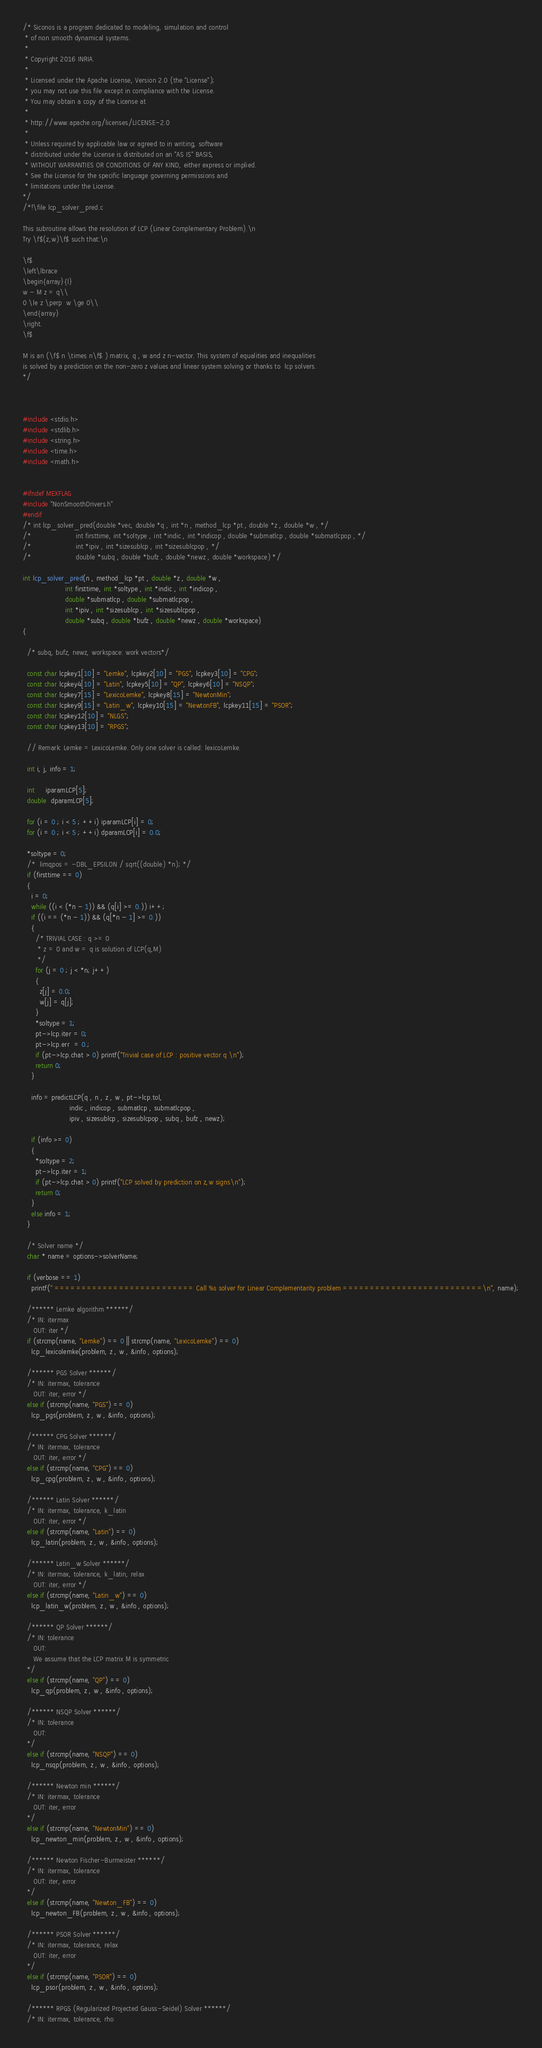<code> <loc_0><loc_0><loc_500><loc_500><_C_>/* Siconos is a program dedicated to modeling, simulation and control
 * of non smooth dynamical systems.
 *
 * Copyright 2016 INRIA.
 *
 * Licensed under the Apache License, Version 2.0 (the "License");
 * you may not use this file except in compliance with the License.
 * You may obtain a copy of the License at
 *
 * http://www.apache.org/licenses/LICENSE-2.0
 *
 * Unless required by applicable law or agreed to in writing, software
 * distributed under the License is distributed on an "AS IS" BASIS,
 * WITHOUT WARRANTIES OR CONDITIONS OF ANY KIND, either express or implied.
 * See the License for the specific language governing permissions and
 * limitations under the License.
*/
/*!\file lcp_solver_pred.c

This subroutine allows the resolution of LCP (Linear Complementary Problem).\n
Try \f$(z,w)\f$ such that:\n

\f$
\left\lbrace
\begin{array}{l}
w - M z = q\\
0 \le z \perp  w \ge 0\\
\end{array}
\right.
\f$

M is an (\f$ n \times n\f$ ) matrix, q , w and z n-vector. This system of equalities and inequalities
is solved by a prediction on the non-zero z values and linear system solving or thanks to  lcp solvers.
*/



#include <stdio.h>
#include <stdlib.h>
#include <string.h>
#include <time.h>
#include <math.h>


#ifndef MEXFLAG
#include "NonSmoothDrivers.h"
#endif
/* int lcp_solver_pred(double *vec, double *q , int *n , method_lcp *pt , double *z , double *w , */
/*                     int firsttime, int *soltype , int *indic , int *indicop , double *submatlcp , double *submatlcpop , */
/*                     int *ipiv , int *sizesublcp , int *sizesublcpop , */
/*                     double *subq , double *bufz , double *newz , double *workspace) */

int lcp_solver_pred(n , method_lcp *pt , double *z , double *w ,
                    int firsttime, int *soltype , int *indic , int *indicop ,
                    double *submatlcp , double *submatlcpop ,
                    int *ipiv , int *sizesublcp , int *sizesublcpop ,
                    double *subq , double *bufz , double *newz , double *workspace)
{

  /* subq, bufz, newz, workspace: work vectors*/

  const char lcpkey1[10] = "Lemke", lcpkey2[10] = "PGS", lcpkey3[10] = "CPG";
  const char lcpkey4[10] = "Latin", lcpkey5[10] = "QP", lcpkey6[10] = "NSQP";
  const char lcpkey7[15] = "LexicoLemke", lcpkey8[15] = "NewtonMin";
  const char lcpkey9[15] = "Latin_w", lcpkey10[15] = "NewtonFB", lcpkey11[15] = "PSOR";
  const char lcpkey12[10] = "NLGS";
  const char lcpkey13[10] = "RPGS";

  // Remark: Lemke = LexicoLemke. Only one solver is called: lexicoLemke.

  int i, j, info = 1;

  int     iparamLCP[5];
  double  dparamLCP[5];

  for (i = 0 ; i < 5 ; ++i) iparamLCP[i] = 0;
  for (i = 0 ; i < 5 ; ++i) dparamLCP[i] = 0.0;

  *soltype = 0;
  /*  limqpos = -DBL_EPSILON / sqrt((double) *n); */
  if (firsttime == 0)
  {
    i = 0;
    while ((i < (*n - 1)) && (q[i] >= 0.)) i++;
    if ((i == (*n - 1)) && (q[*n - 1] >= 0.))
    {
      /* TRIVIAL CASE : q >= 0
       * z = 0 and w = q is solution of LCP(q,M)
       */
      for (j = 0 ; j < *n; j++)
      {
        z[j] = 0.0;
        w[j] = q[j];
      }
      *soltype = 1;
      pt->lcp.iter = 0;
      pt->lcp.err  = 0.;
      if (pt->lcp.chat > 0) printf("Trivial case of LCP : positive vector q \n");
      return 0;
    }

    info = predictLCP(q , n , z , w , pt->lcp.tol,
                      indic , indicop , submatlcp , submatlcpop ,
                      ipiv , sizesublcp , sizesublcpop , subq , bufz , newz);

    if (info >= 0)
    {
      *soltype = 2;
      pt->lcp.iter = 1;
      if (pt->lcp.chat > 0) printf("LCP solved by prediction on z,w signs\n");
      return 0;
    }
    else info = 1;
  }

  /* Solver name */
  char * name = options->solverName;

  if (verbose == 1)
    printf(" ========================== Call %s solver for Linear Complementarity problem ==========================\n", name);

  /****** Lemke algorithm ******/
  /* IN: itermax
     OUT: iter */
  if (strcmp(name, "Lemke") == 0 || strcmp(name, "LexicoLemke") == 0)
    lcp_lexicolemke(problem, z , w , &info , options);

  /****** PGS Solver ******/
  /* IN: itermax, tolerance
     OUT: iter, error */
  else if (strcmp(name, "PGS") == 0)
    lcp_pgs(problem, z , w , &info , options);

  /****** CPG Solver ******/
  /* IN: itermax, tolerance
     OUT: iter, error */
  else if (strcmp(name, "CPG") == 0)
    lcp_cpg(problem, z , w , &info , options);

  /****** Latin Solver ******/
  /* IN: itermax, tolerance, k_latin
     OUT: iter, error */
  else if (strcmp(name, "Latin") == 0)
    lcp_latin(problem, z , w , &info , options);

  /****** Latin_w Solver ******/
  /* IN: itermax, tolerance, k_latin, relax
     OUT: iter, error */
  else if (strcmp(name, "Latin_w") == 0)
    lcp_latin_w(problem, z , w , &info , options);

  /****** QP Solver ******/
  /* IN: tolerance
     OUT:
     We assume that the LCP matrix M is symmetric
  */
  else if (strcmp(name, "QP") == 0)
    lcp_qp(problem, z , w , &info , options);

  /****** NSQP Solver ******/
  /* IN: tolerance
     OUT:
  */
  else if (strcmp(name, "NSQP") == 0)
    lcp_nsqp(problem, z , w , &info , options);

  /****** Newton min ******/
  /* IN: itermax, tolerance
     OUT: iter, error
  */
  else if (strcmp(name, "NewtonMin") == 0)
    lcp_newton_min(problem, z , w , &info , options);

  /****** Newton Fischer-Burmeister ******/
  /* IN: itermax, tolerance
     OUT: iter, error
  */
  else if (strcmp(name, "Newton_FB") == 0)
    lcp_newton_FB(problem, z , w , &info , options);

  /****** PSOR Solver ******/
  /* IN: itermax, tolerance, relax
     OUT: iter, error
  */
  else if (strcmp(name, "PSOR") == 0)
    lcp_psor(problem, z , w , &info , options);

  /****** RPGS (Regularized Projected Gauss-Seidel) Solver ******/
  /* IN: itermax, tolerance, rho</code> 